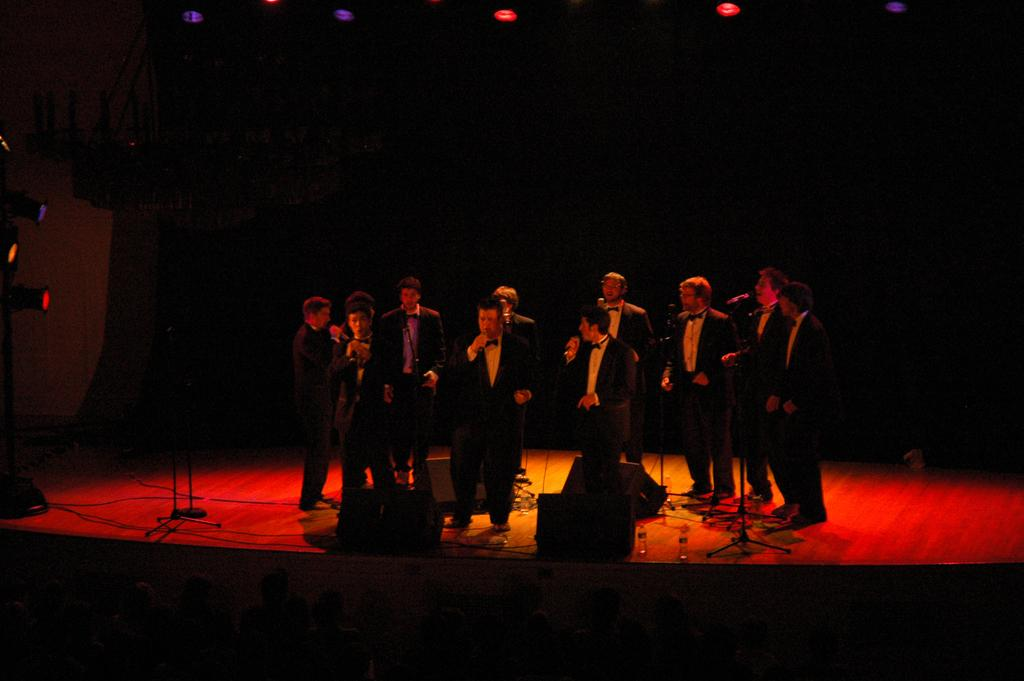What are the people on the stage doing? The people on the stage are singing. What tools are being used by the singers? There are microphones visible in the image. How is the sound being amplified for the audience? There are speakers present in the image. What can be seen illuminating the stage? There are lights visible in the image. What is the color of the background in the image? The background of the image is dark. What type of body is being rewarded with a word in the image? There is no body, reward, or word present in the image; it features people singing on a stage. 